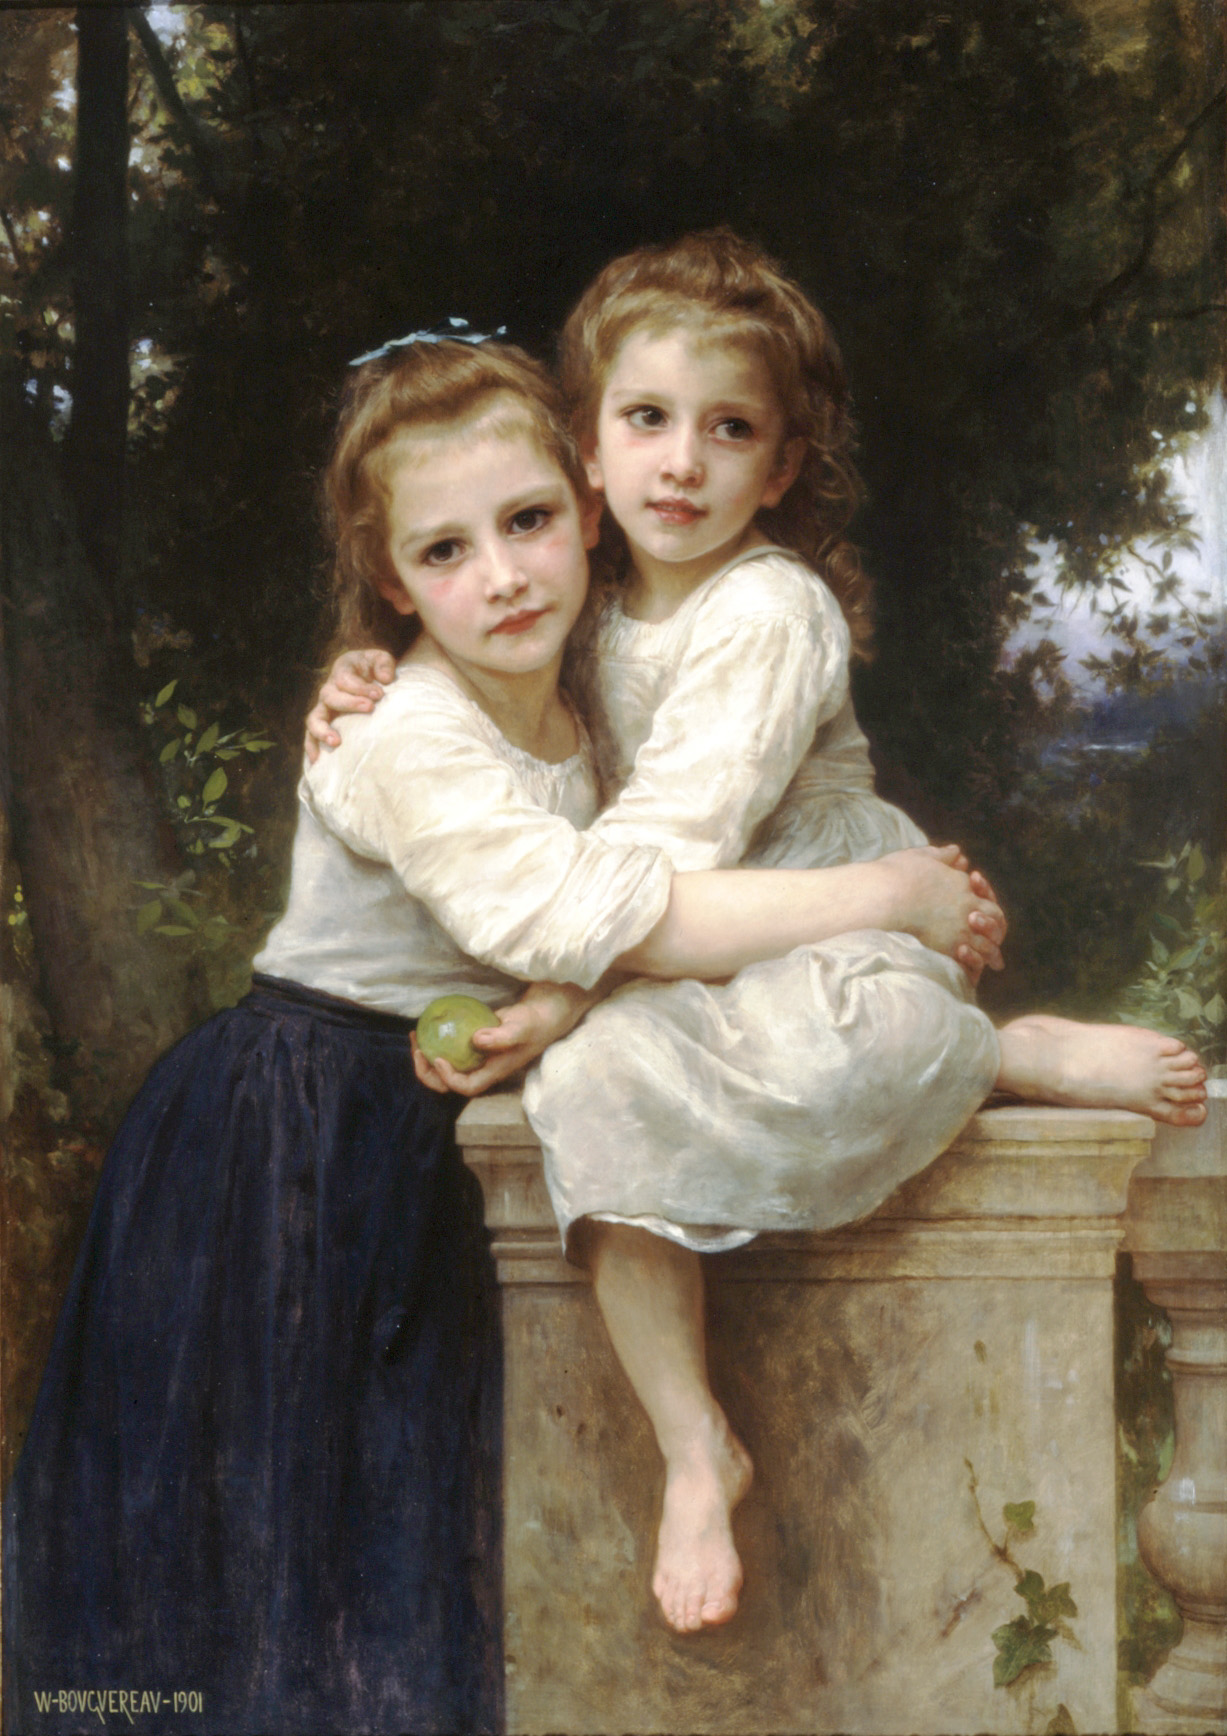If you could step into the painting, what do you think you would hear and smell? If one could step into the painting, the air would likely be filled with the soothing sounds of nature – the gentle rustling of leaves, the distant chirping of birds, and perhaps the soft murmur of a breeze passing through the garden. The vivid greenery would emit fresh, earthy aromas combined with the subtle fragrance of blooming flowers. The scent of the stone balustrade, warmed by the sun, would contribute a hint of mineral-like essence, blending seamlessly with the natural bouquet. Can you create a short story based on this painting? In a quaint, secluded village, nestled within the heart of a picturesque countryside, two sisters named Emily and Clara found solace in each other’s company. On this particular day, they discovered an old, forgotten garden enclosure, hidden behind rows of ivy-draped walls. The girls eagerly explored, their eyes wide with wonder, as they stumbled upon a weathered stone balustrade. Overwhelmed by the beauty of their hidden sanctuary, they sat together, Emily clutching a green apple she had picked from a nearby tree. As they leaned into each other’s embrace, the tranquility of the garden seemed to wrap around them, shielding them from the world beyond. They talked in hushed tones about their dreams and whispered secrets, knowing that in this serene haven, they could hold onto the purity and simplicity of their childhood for just a while longer. 